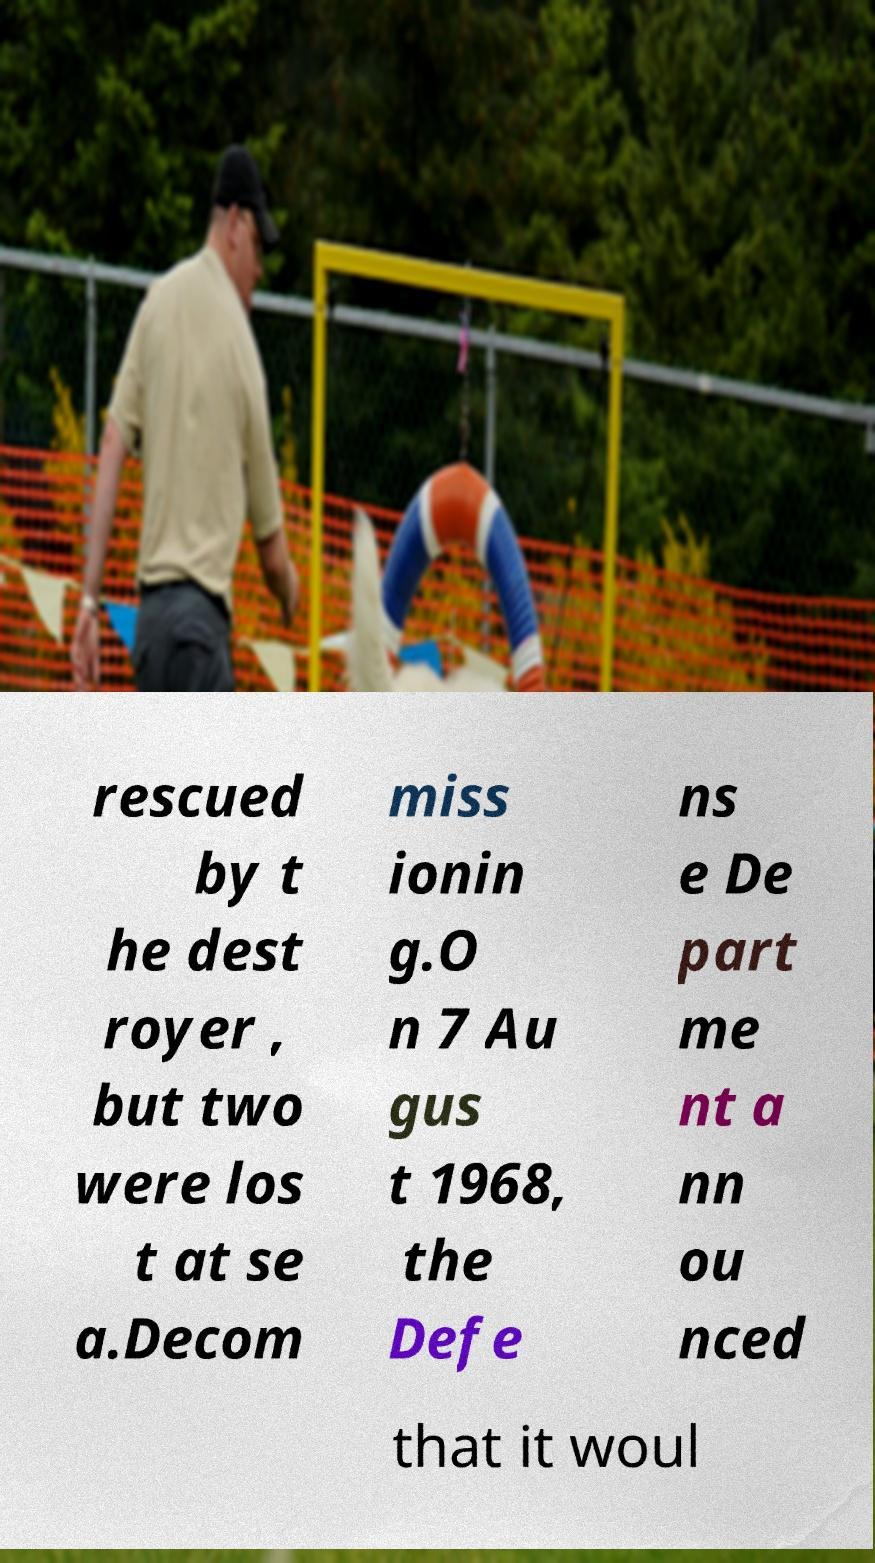There's text embedded in this image that I need extracted. Can you transcribe it verbatim? rescued by t he dest royer , but two were los t at se a.Decom miss ionin g.O n 7 Au gus t 1968, the Defe ns e De part me nt a nn ou nced that it woul 